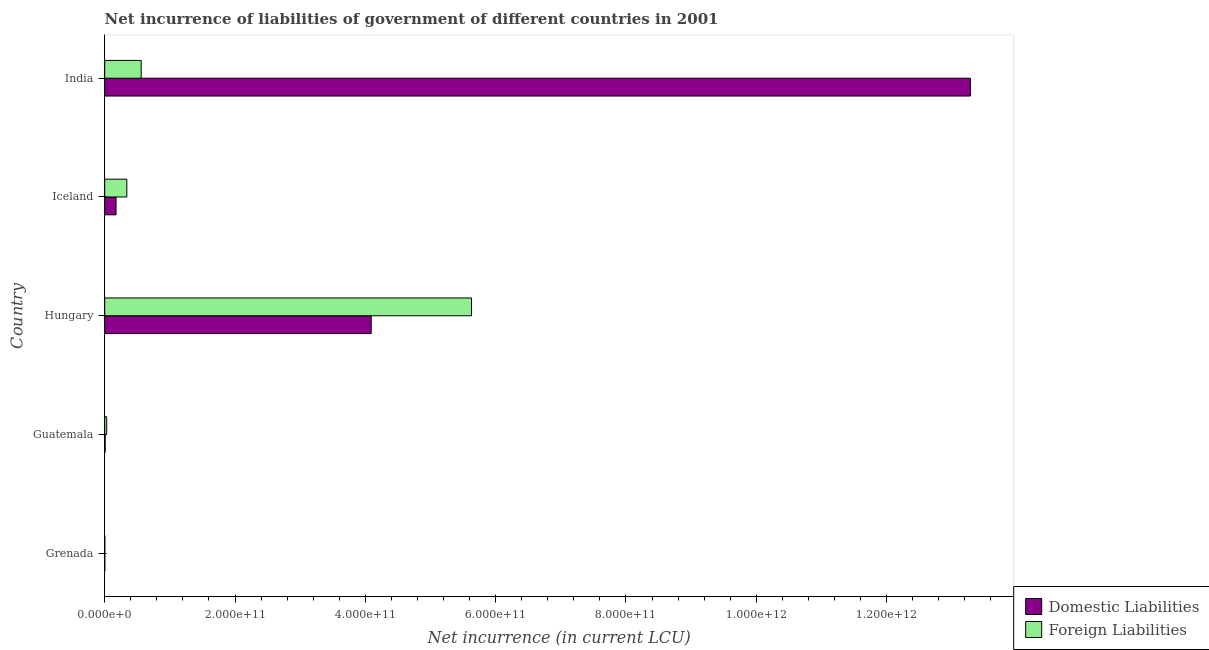Are the number of bars on each tick of the Y-axis equal?
Your answer should be very brief. Yes. How many bars are there on the 1st tick from the top?
Keep it short and to the point. 2. How many bars are there on the 1st tick from the bottom?
Ensure brevity in your answer.  2. What is the label of the 3rd group of bars from the top?
Give a very brief answer. Hungary. What is the net incurrence of domestic liabilities in Grenada?
Make the answer very short. 4.57e+07. Across all countries, what is the maximum net incurrence of domestic liabilities?
Your answer should be very brief. 1.33e+12. Across all countries, what is the minimum net incurrence of domestic liabilities?
Keep it short and to the point. 4.57e+07. In which country was the net incurrence of foreign liabilities minimum?
Your response must be concise. Grenada. What is the total net incurrence of domestic liabilities in the graph?
Your response must be concise. 1.76e+12. What is the difference between the net incurrence of domestic liabilities in Hungary and that in Iceland?
Ensure brevity in your answer.  3.92e+11. What is the difference between the net incurrence of foreign liabilities in Iceland and the net incurrence of domestic liabilities in India?
Keep it short and to the point. -1.29e+12. What is the average net incurrence of domestic liabilities per country?
Offer a terse response. 3.51e+11. What is the difference between the net incurrence of domestic liabilities and net incurrence of foreign liabilities in Grenada?
Provide a short and direct response. -1.02e+07. In how many countries, is the net incurrence of foreign liabilities greater than 280000000000 LCU?
Give a very brief answer. 1. What is the ratio of the net incurrence of foreign liabilities in Grenada to that in India?
Make the answer very short. 0. Is the difference between the net incurrence of domestic liabilities in Guatemala and Hungary greater than the difference between the net incurrence of foreign liabilities in Guatemala and Hungary?
Your answer should be compact. Yes. What is the difference between the highest and the second highest net incurrence of domestic liabilities?
Your response must be concise. 9.20e+11. What is the difference between the highest and the lowest net incurrence of foreign liabilities?
Offer a terse response. 5.63e+11. What does the 1st bar from the top in Hungary represents?
Keep it short and to the point. Foreign Liabilities. What does the 1st bar from the bottom in Grenada represents?
Ensure brevity in your answer.  Domestic Liabilities. How many bars are there?
Ensure brevity in your answer.  10. Are all the bars in the graph horizontal?
Provide a succinct answer. Yes. How many countries are there in the graph?
Your response must be concise. 5. What is the difference between two consecutive major ticks on the X-axis?
Keep it short and to the point. 2.00e+11. Does the graph contain any zero values?
Provide a succinct answer. No. How many legend labels are there?
Provide a short and direct response. 2. What is the title of the graph?
Provide a short and direct response. Net incurrence of liabilities of government of different countries in 2001. What is the label or title of the X-axis?
Keep it short and to the point. Net incurrence (in current LCU). What is the Net incurrence (in current LCU) in Domestic Liabilities in Grenada?
Ensure brevity in your answer.  4.57e+07. What is the Net incurrence (in current LCU) in Foreign Liabilities in Grenada?
Offer a very short reply. 5.59e+07. What is the Net incurrence (in current LCU) in Domestic Liabilities in Guatemala?
Provide a succinct answer. 6.51e+08. What is the Net incurrence (in current LCU) of Foreign Liabilities in Guatemala?
Make the answer very short. 3.05e+09. What is the Net incurrence (in current LCU) in Domestic Liabilities in Hungary?
Make the answer very short. 4.09e+11. What is the Net incurrence (in current LCU) in Foreign Liabilities in Hungary?
Give a very brief answer. 5.63e+11. What is the Net incurrence (in current LCU) of Domestic Liabilities in Iceland?
Offer a very short reply. 1.74e+1. What is the Net incurrence (in current LCU) in Foreign Liabilities in Iceland?
Offer a terse response. 3.39e+1. What is the Net incurrence (in current LCU) in Domestic Liabilities in India?
Your answer should be compact. 1.33e+12. What is the Net incurrence (in current LCU) in Foreign Liabilities in India?
Give a very brief answer. 5.60e+1. Across all countries, what is the maximum Net incurrence (in current LCU) of Domestic Liabilities?
Your answer should be very brief. 1.33e+12. Across all countries, what is the maximum Net incurrence (in current LCU) of Foreign Liabilities?
Keep it short and to the point. 5.63e+11. Across all countries, what is the minimum Net incurrence (in current LCU) in Domestic Liabilities?
Offer a terse response. 4.57e+07. Across all countries, what is the minimum Net incurrence (in current LCU) in Foreign Liabilities?
Make the answer very short. 5.59e+07. What is the total Net incurrence (in current LCU) of Domestic Liabilities in the graph?
Your answer should be very brief. 1.76e+12. What is the total Net incurrence (in current LCU) in Foreign Liabilities in the graph?
Your answer should be very brief. 6.56e+11. What is the difference between the Net incurrence (in current LCU) of Domestic Liabilities in Grenada and that in Guatemala?
Provide a short and direct response. -6.05e+08. What is the difference between the Net incurrence (in current LCU) of Foreign Liabilities in Grenada and that in Guatemala?
Give a very brief answer. -3.00e+09. What is the difference between the Net incurrence (in current LCU) of Domestic Liabilities in Grenada and that in Hungary?
Ensure brevity in your answer.  -4.09e+11. What is the difference between the Net incurrence (in current LCU) of Foreign Liabilities in Grenada and that in Hungary?
Offer a terse response. -5.63e+11. What is the difference between the Net incurrence (in current LCU) in Domestic Liabilities in Grenada and that in Iceland?
Offer a very short reply. -1.74e+1. What is the difference between the Net incurrence (in current LCU) in Foreign Liabilities in Grenada and that in Iceland?
Keep it short and to the point. -3.39e+1. What is the difference between the Net incurrence (in current LCU) in Domestic Liabilities in Grenada and that in India?
Your answer should be very brief. -1.33e+12. What is the difference between the Net incurrence (in current LCU) of Foreign Liabilities in Grenada and that in India?
Offer a very short reply. -5.60e+1. What is the difference between the Net incurrence (in current LCU) in Domestic Liabilities in Guatemala and that in Hungary?
Provide a succinct answer. -4.08e+11. What is the difference between the Net incurrence (in current LCU) in Foreign Liabilities in Guatemala and that in Hungary?
Your response must be concise. -5.60e+11. What is the difference between the Net incurrence (in current LCU) of Domestic Liabilities in Guatemala and that in Iceland?
Make the answer very short. -1.68e+1. What is the difference between the Net incurrence (in current LCU) of Foreign Liabilities in Guatemala and that in Iceland?
Your answer should be very brief. -3.09e+1. What is the difference between the Net incurrence (in current LCU) in Domestic Liabilities in Guatemala and that in India?
Keep it short and to the point. -1.33e+12. What is the difference between the Net incurrence (in current LCU) of Foreign Liabilities in Guatemala and that in India?
Offer a terse response. -5.30e+1. What is the difference between the Net incurrence (in current LCU) of Domestic Liabilities in Hungary and that in Iceland?
Keep it short and to the point. 3.92e+11. What is the difference between the Net incurrence (in current LCU) of Foreign Liabilities in Hungary and that in Iceland?
Offer a very short reply. 5.29e+11. What is the difference between the Net incurrence (in current LCU) of Domestic Liabilities in Hungary and that in India?
Give a very brief answer. -9.20e+11. What is the difference between the Net incurrence (in current LCU) of Foreign Liabilities in Hungary and that in India?
Provide a short and direct response. 5.07e+11. What is the difference between the Net incurrence (in current LCU) of Domestic Liabilities in Iceland and that in India?
Give a very brief answer. -1.31e+12. What is the difference between the Net incurrence (in current LCU) in Foreign Liabilities in Iceland and that in India?
Your response must be concise. -2.21e+1. What is the difference between the Net incurrence (in current LCU) in Domestic Liabilities in Grenada and the Net incurrence (in current LCU) in Foreign Liabilities in Guatemala?
Your response must be concise. -3.01e+09. What is the difference between the Net incurrence (in current LCU) of Domestic Liabilities in Grenada and the Net incurrence (in current LCU) of Foreign Liabilities in Hungary?
Keep it short and to the point. -5.63e+11. What is the difference between the Net incurrence (in current LCU) of Domestic Liabilities in Grenada and the Net incurrence (in current LCU) of Foreign Liabilities in Iceland?
Offer a very short reply. -3.39e+1. What is the difference between the Net incurrence (in current LCU) of Domestic Liabilities in Grenada and the Net incurrence (in current LCU) of Foreign Liabilities in India?
Offer a terse response. -5.60e+1. What is the difference between the Net incurrence (in current LCU) of Domestic Liabilities in Guatemala and the Net incurrence (in current LCU) of Foreign Liabilities in Hungary?
Provide a short and direct response. -5.62e+11. What is the difference between the Net incurrence (in current LCU) in Domestic Liabilities in Guatemala and the Net incurrence (in current LCU) in Foreign Liabilities in Iceland?
Give a very brief answer. -3.33e+1. What is the difference between the Net incurrence (in current LCU) of Domestic Liabilities in Guatemala and the Net incurrence (in current LCU) of Foreign Liabilities in India?
Make the answer very short. -5.54e+1. What is the difference between the Net incurrence (in current LCU) of Domestic Liabilities in Hungary and the Net incurrence (in current LCU) of Foreign Liabilities in Iceland?
Keep it short and to the point. 3.75e+11. What is the difference between the Net incurrence (in current LCU) of Domestic Liabilities in Hungary and the Net incurrence (in current LCU) of Foreign Liabilities in India?
Provide a succinct answer. 3.53e+11. What is the difference between the Net incurrence (in current LCU) in Domestic Liabilities in Iceland and the Net incurrence (in current LCU) in Foreign Liabilities in India?
Your answer should be very brief. -3.86e+1. What is the average Net incurrence (in current LCU) in Domestic Liabilities per country?
Offer a very short reply. 3.51e+11. What is the average Net incurrence (in current LCU) of Foreign Liabilities per country?
Your response must be concise. 1.31e+11. What is the difference between the Net incurrence (in current LCU) in Domestic Liabilities and Net incurrence (in current LCU) in Foreign Liabilities in Grenada?
Your response must be concise. -1.02e+07. What is the difference between the Net incurrence (in current LCU) of Domestic Liabilities and Net incurrence (in current LCU) of Foreign Liabilities in Guatemala?
Give a very brief answer. -2.40e+09. What is the difference between the Net incurrence (in current LCU) in Domestic Liabilities and Net incurrence (in current LCU) in Foreign Liabilities in Hungary?
Keep it short and to the point. -1.54e+11. What is the difference between the Net incurrence (in current LCU) in Domestic Liabilities and Net incurrence (in current LCU) in Foreign Liabilities in Iceland?
Provide a succinct answer. -1.65e+1. What is the difference between the Net incurrence (in current LCU) in Domestic Liabilities and Net incurrence (in current LCU) in Foreign Liabilities in India?
Make the answer very short. 1.27e+12. What is the ratio of the Net incurrence (in current LCU) in Domestic Liabilities in Grenada to that in Guatemala?
Your answer should be compact. 0.07. What is the ratio of the Net incurrence (in current LCU) in Foreign Liabilities in Grenada to that in Guatemala?
Ensure brevity in your answer.  0.02. What is the ratio of the Net incurrence (in current LCU) of Domestic Liabilities in Grenada to that in Iceland?
Make the answer very short. 0. What is the ratio of the Net incurrence (in current LCU) in Foreign Liabilities in Grenada to that in Iceland?
Provide a succinct answer. 0. What is the ratio of the Net incurrence (in current LCU) in Foreign Liabilities in Grenada to that in India?
Your answer should be compact. 0. What is the ratio of the Net incurrence (in current LCU) in Domestic Liabilities in Guatemala to that in Hungary?
Ensure brevity in your answer.  0. What is the ratio of the Net incurrence (in current LCU) of Foreign Liabilities in Guatemala to that in Hungary?
Your response must be concise. 0.01. What is the ratio of the Net incurrence (in current LCU) in Domestic Liabilities in Guatemala to that in Iceland?
Keep it short and to the point. 0.04. What is the ratio of the Net incurrence (in current LCU) of Foreign Liabilities in Guatemala to that in Iceland?
Make the answer very short. 0.09. What is the ratio of the Net incurrence (in current LCU) in Domestic Liabilities in Guatemala to that in India?
Make the answer very short. 0. What is the ratio of the Net incurrence (in current LCU) of Foreign Liabilities in Guatemala to that in India?
Offer a terse response. 0.05. What is the ratio of the Net incurrence (in current LCU) in Domestic Liabilities in Hungary to that in Iceland?
Offer a very short reply. 23.49. What is the ratio of the Net incurrence (in current LCU) in Foreign Liabilities in Hungary to that in Iceland?
Your answer should be very brief. 16.59. What is the ratio of the Net incurrence (in current LCU) of Domestic Liabilities in Hungary to that in India?
Provide a succinct answer. 0.31. What is the ratio of the Net incurrence (in current LCU) of Foreign Liabilities in Hungary to that in India?
Keep it short and to the point. 10.05. What is the ratio of the Net incurrence (in current LCU) of Domestic Liabilities in Iceland to that in India?
Give a very brief answer. 0.01. What is the ratio of the Net incurrence (in current LCU) in Foreign Liabilities in Iceland to that in India?
Give a very brief answer. 0.61. What is the difference between the highest and the second highest Net incurrence (in current LCU) in Domestic Liabilities?
Your response must be concise. 9.20e+11. What is the difference between the highest and the second highest Net incurrence (in current LCU) of Foreign Liabilities?
Provide a succinct answer. 5.07e+11. What is the difference between the highest and the lowest Net incurrence (in current LCU) in Domestic Liabilities?
Your answer should be compact. 1.33e+12. What is the difference between the highest and the lowest Net incurrence (in current LCU) in Foreign Liabilities?
Your answer should be compact. 5.63e+11. 